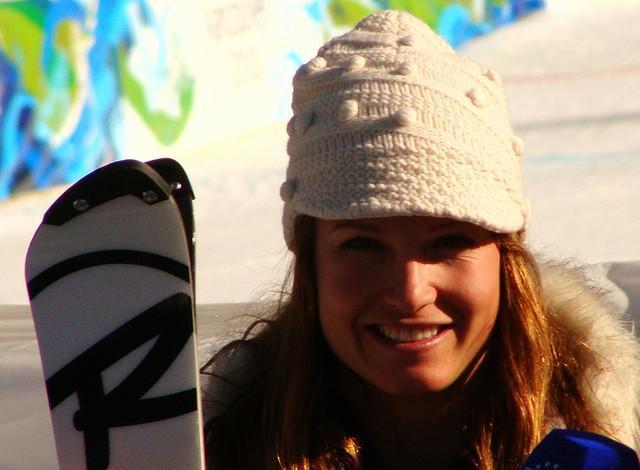How many skateboards do you see?
Give a very brief answer. 0. 